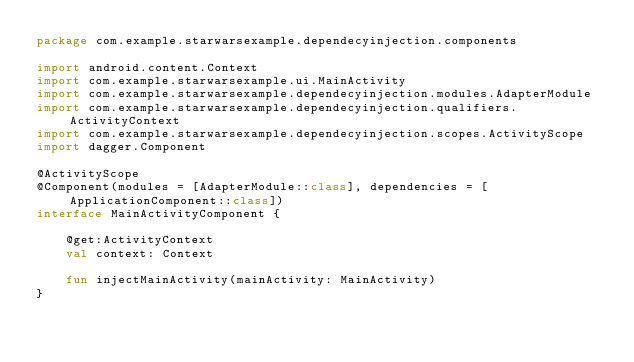Convert code to text. <code><loc_0><loc_0><loc_500><loc_500><_Kotlin_>package com.example.starwarsexample.dependecyinjection.components

import android.content.Context
import com.example.starwarsexample.ui.MainActivity
import com.example.starwarsexample.dependecyinjection.modules.AdapterModule
import com.example.starwarsexample.dependecyinjection.qualifiers.ActivityContext
import com.example.starwarsexample.dependecyinjection.scopes.ActivityScope
import dagger.Component

@ActivityScope
@Component(modules = [AdapterModule::class], dependencies = [ApplicationComponent::class])
interface MainActivityComponent {

    @get:ActivityContext
    val context: Context

    fun injectMainActivity(mainActivity: MainActivity)
}
</code> 